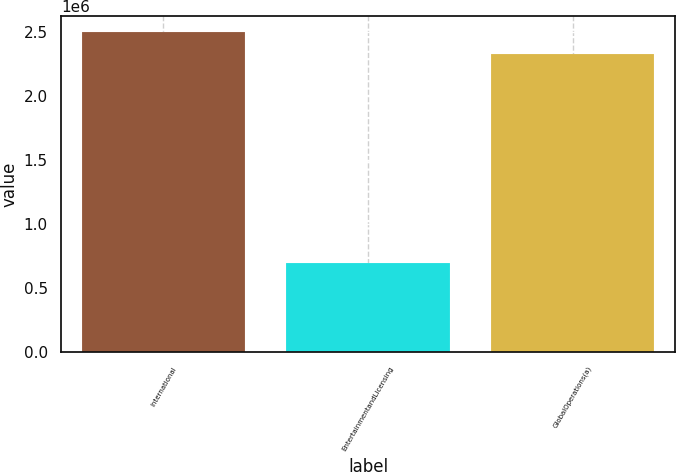<chart> <loc_0><loc_0><loc_500><loc_500><bar_chart><fcel>International<fcel>EntertainmentandLicensing<fcel>GlobalOperations(a)<nl><fcel>2.49415e+06<fcel>692898<fcel>2.32657e+06<nl></chart> 